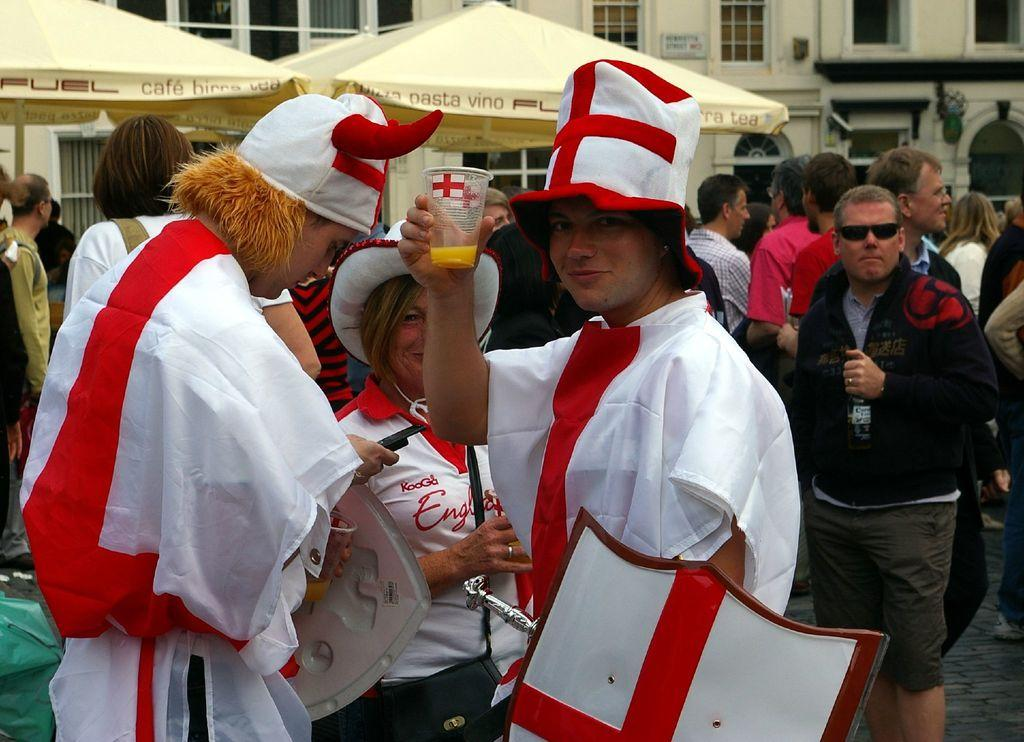What can be observed about the people in the image? There are three persons wearing costumes in the image. What else can be seen in the background of the image? There are people, tents, and buildings in the background of the image. What type of potato is being used to provide shade for the people in the image? There is no potato present in the image, and therefore no such activity can be observed. 